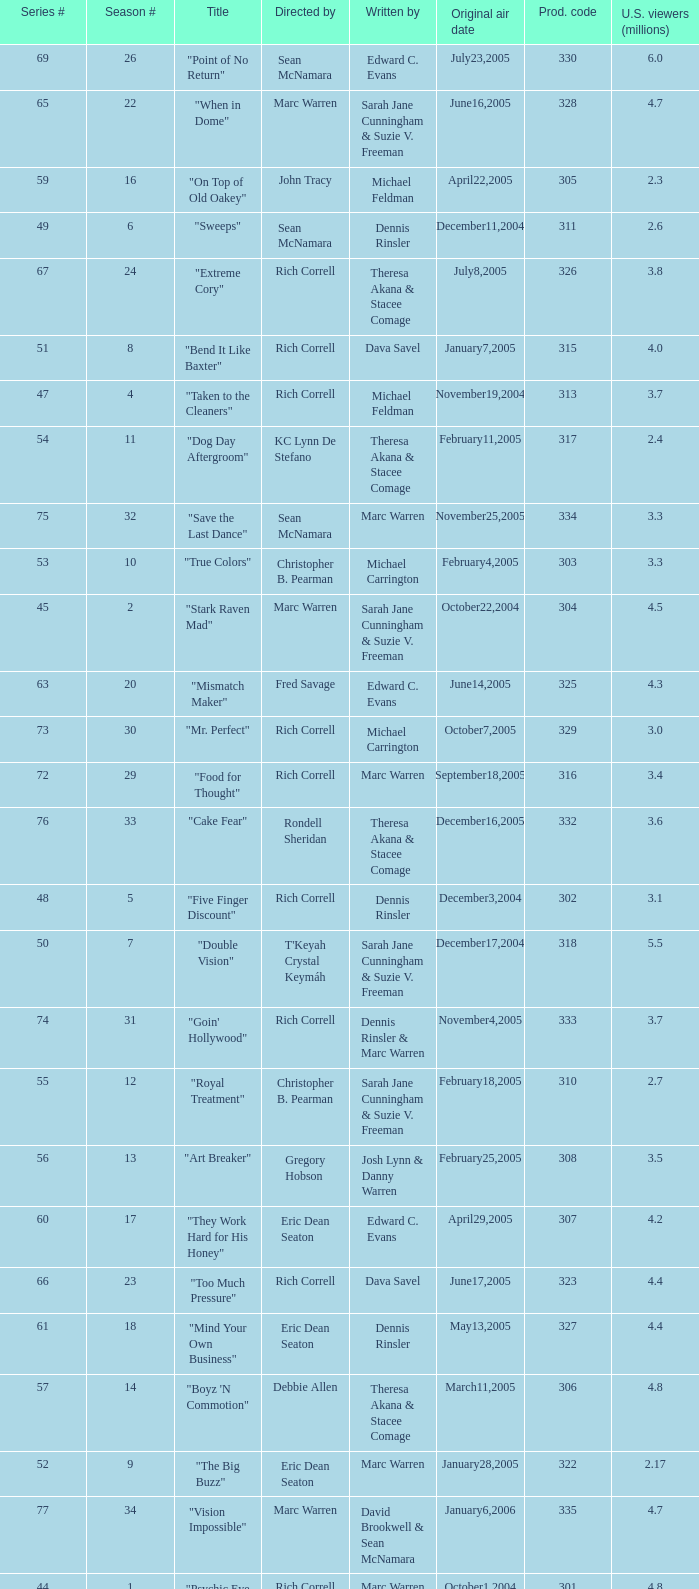Can you parse all the data within this table? {'header': ['Series #', 'Season #', 'Title', 'Directed by', 'Written by', 'Original air date', 'Prod. code', 'U.S. viewers (millions)'], 'rows': [['69', '26', '"Point of No Return"', 'Sean McNamara', 'Edward C. Evans', 'July23,2005', '330', '6.0'], ['65', '22', '"When in Dome"', 'Marc Warren', 'Sarah Jane Cunningham & Suzie V. Freeman', 'June16,2005', '328', '4.7'], ['59', '16', '"On Top of Old Oakey"', 'John Tracy', 'Michael Feldman', 'April22,2005', '305', '2.3'], ['49', '6', '"Sweeps"', 'Sean McNamara', 'Dennis Rinsler', 'December11,2004', '311', '2.6'], ['67', '24', '"Extreme Cory"', 'Rich Correll', 'Theresa Akana & Stacee Comage', 'July8,2005', '326', '3.8'], ['51', '8', '"Bend It Like Baxter"', 'Rich Correll', 'Dava Savel', 'January7,2005', '315', '4.0'], ['47', '4', '"Taken to the Cleaners"', 'Rich Correll', 'Michael Feldman', 'November19,2004', '313', '3.7'], ['54', '11', '"Dog Day Aftergroom"', 'KC Lynn De Stefano', 'Theresa Akana & Stacee Comage', 'February11,2005', '317', '2.4'], ['75', '32', '"Save the Last Dance"', 'Sean McNamara', 'Marc Warren', 'November25,2005', '334', '3.3'], ['53', '10', '"True Colors"', 'Christopher B. Pearman', 'Michael Carrington', 'February4,2005', '303', '3.3'], ['45', '2', '"Stark Raven Mad"', 'Marc Warren', 'Sarah Jane Cunningham & Suzie V. Freeman', 'October22,2004', '304', '4.5'], ['63', '20', '"Mismatch Maker"', 'Fred Savage', 'Edward C. Evans', 'June14,2005', '325', '4.3'], ['73', '30', '"Mr. Perfect"', 'Rich Correll', 'Michael Carrington', 'October7,2005', '329', '3.0'], ['72', '29', '"Food for Thought"', 'Rich Correll', 'Marc Warren', 'September18,2005', '316', '3.4'], ['76', '33', '"Cake Fear"', 'Rondell Sheridan', 'Theresa Akana & Stacee Comage', 'December16,2005', '332', '3.6'], ['48', '5', '"Five Finger Discount"', 'Rich Correll', 'Dennis Rinsler', 'December3,2004', '302', '3.1'], ['50', '7', '"Double Vision"', "T'Keyah Crystal Keymáh", 'Sarah Jane Cunningham & Suzie V. Freeman', 'December17,2004', '318', '5.5'], ['74', '31', '"Goin\' Hollywood"', 'Rich Correll', 'Dennis Rinsler & Marc Warren', 'November4,2005', '333', '3.7'], ['55', '12', '"Royal Treatment"', 'Christopher B. Pearman', 'Sarah Jane Cunningham & Suzie V. Freeman', 'February18,2005', '310', '2.7'], ['56', '13', '"Art Breaker"', 'Gregory Hobson', 'Josh Lynn & Danny Warren', 'February25,2005', '308', '3.5'], ['60', '17', '"They Work Hard for His Honey"', 'Eric Dean Seaton', 'Edward C. Evans', 'April29,2005', '307', '4.2'], ['66', '23', '"Too Much Pressure"', 'Rich Correll', 'Dava Savel', 'June17,2005', '323', '4.4'], ['61', '18', '"Mind Your Own Business"', 'Eric Dean Seaton', 'Dennis Rinsler', 'May13,2005', '327', '4.4'], ['57', '14', '"Boyz \'N Commotion"', 'Debbie Allen', 'Theresa Akana & Stacee Comage', 'March11,2005', '306', '4.8'], ['52', '9', '"The Big Buzz"', 'Eric Dean Seaton', 'Marc Warren', 'January28,2005', '322', '2.17'], ['77', '34', '"Vision Impossible"', 'Marc Warren', 'David Brookwell & Sean McNamara', 'January6,2006', '335', '4.7'], ['44', '1', '"Psychic Eye for the Sloppy Guy"', 'Rich Correll', 'Marc Warren', 'October1,2004', '301', '4.8'], ['46', '3', '"Opportunity Shocks"', 'Rich Correll', 'Dava Savel', 'November5,2004', '309', '4.5'], ['68', '25', '"The Grill Next Door"', 'Sean McNamara', 'Michael Feldman', 'July8,2005', '324', '4.23'], ['58', '15', '"Gettin\' Outta Dodge"', 'Rich Correll', 'Edward C. Evans', 'April8,2005', '319', '2.1'], ['62', '19', '"Hizzouse Party"', 'Rich Correll', 'Michael Carrington', 'June13,2005', '312', '5.1']]} What is the title of the episode directed by Rich Correll and written by Dennis Rinsler? "Five Finger Discount". 